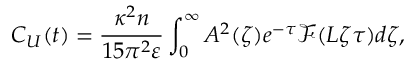Convert formula to latex. <formula><loc_0><loc_0><loc_500><loc_500>C _ { U } ( t ) = \frac { \kappa ^ { 2 } n } { 1 5 \pi ^ { 2 } \varepsilon } \int _ { 0 } ^ { \infty } A ^ { 2 } ( \zeta ) e ^ { - \tau } \mathcal { F } ( L \zeta \tau ) d \zeta ,</formula> 